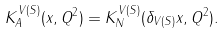<formula> <loc_0><loc_0><loc_500><loc_500>K ^ { V ( S ) } _ { A } ( x , Q ^ { 2 } ) = K ^ { V ( S ) } _ { N } ( \delta _ { V ( S ) } x , Q ^ { 2 } ) .</formula> 